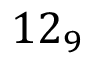Convert formula to latex. <formula><loc_0><loc_0><loc_500><loc_500>1 2 _ { 9 }</formula> 